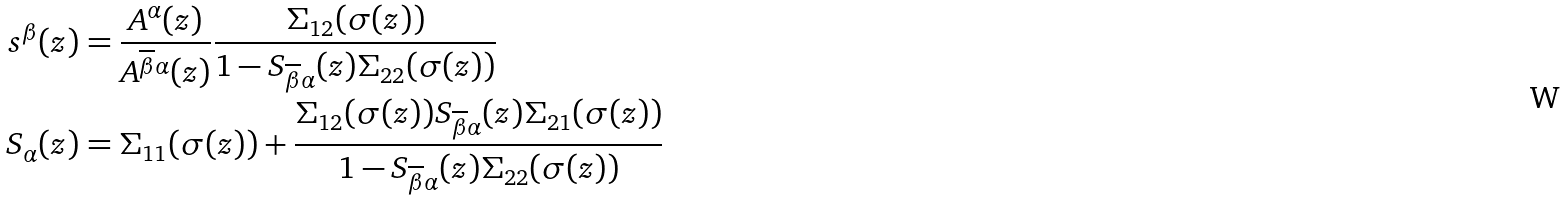Convert formula to latex. <formula><loc_0><loc_0><loc_500><loc_500>s ^ { \beta } ( z ) & = \frac { A ^ { \alpha } ( z ) } { A ^ { \overline { \beta } \alpha } ( z ) } \frac { \Sigma _ { 1 2 } ( \sigma ( z ) ) } { 1 - S _ { { \overline { \beta } \alpha } } ( z ) \Sigma _ { 2 2 } ( \sigma ( z ) ) } \\ S _ { \alpha } ( z ) & = \Sigma _ { 1 1 } ( \sigma ( z ) ) + \frac { \Sigma _ { 1 2 } ( \sigma ( z ) ) S _ { \overline { \beta } \alpha } ( z ) \Sigma _ { 2 1 } ( \sigma ( z ) ) } { 1 - S _ { \overline { \beta } \alpha } ( z ) \Sigma _ { 2 2 } ( \sigma ( z ) ) }</formula> 